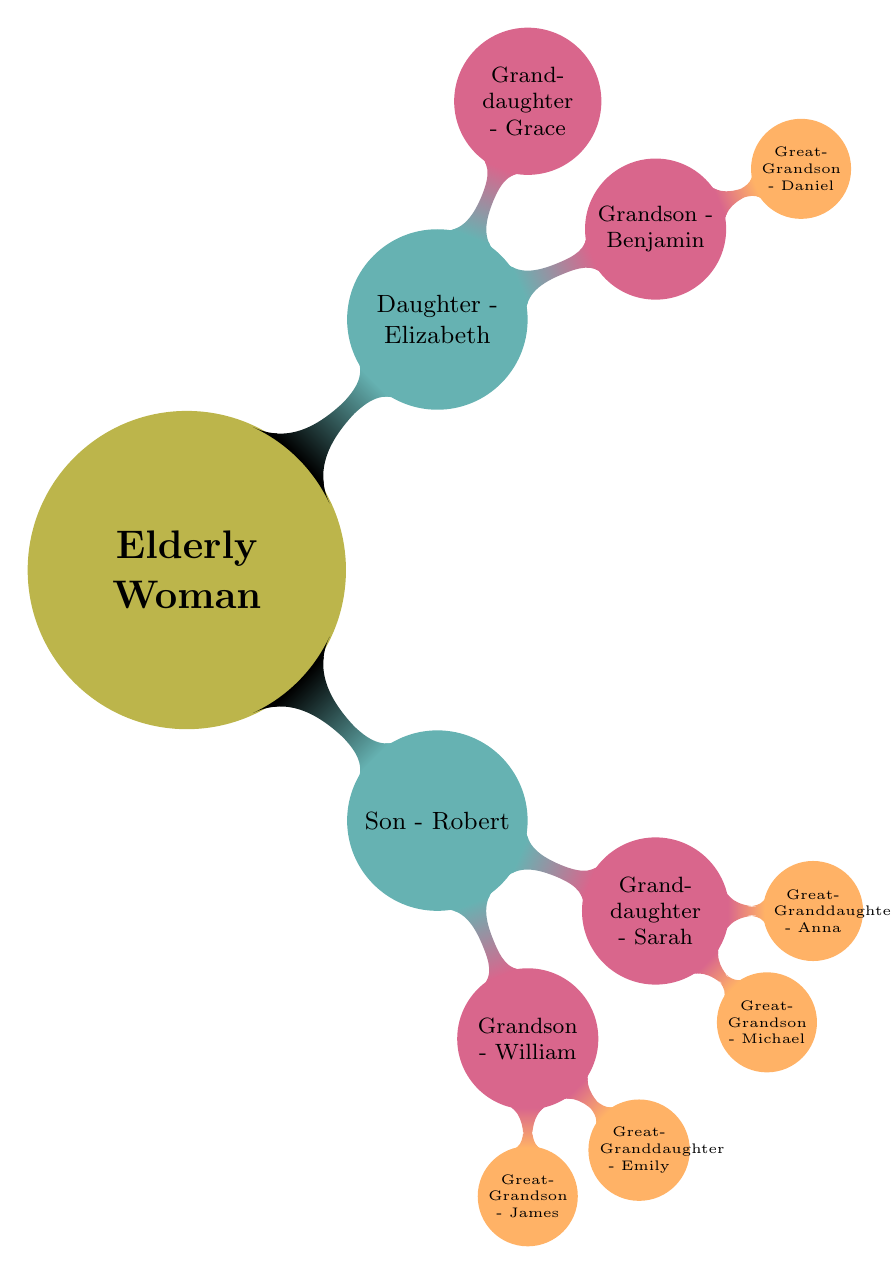What is the root node of the diagram? The root node is labeled "Elderly Woman," which represents the starting point of the family tree.
Answer: Elderly Woman How many children does the Elderly Woman have? The diagram shows two direct children of the Elderly Woman: a son named Robert and a daughter named Elizabeth. Therefore, the count is two.
Answer: 2 Who is the grandson of the Elderly Woman? The grandson is William, who is the child of Robert, one of the Elderly Woman's two children.
Answer: William How many great-grandchildren does Son Robert have? Son Robert has two grandchildren listed, William and Sarah. Each of them has two children, resulting in four great-grandchildren: James, Emily, Michael, and Anna.
Answer: 4 Which granddaughter of the Elderly Woman has a child? The granddaughter Benjamin of Elizabeth is the only one listed who has a child, specifically a great-grandson named Daniel.
Answer: Benjamin How many total generations are depicted in the diagram? The diagram includes four generations: the Elderly Woman (first generation), her children Robert and Elizabeth (second generation), their grandchildren (third generation), and the great-grandchildren (fourth generation), making the total count four generations.
Answer: 4 Who is the great-granddaughter of the Elderly Woman? There are two great-granddaughters listed in the tree: Emily (daughter of William) and Anna (daughter of Sarah).
Answer: Emily and Anna Which child of the Elderly Woman has more children? Son Robert has two children (William and Sarah), while Daughter Elizabeth has two children (Benjamin and Grace). Both children have the same number of children, but Robert's children have children of their own, leading to more total offspring descending from him.
Answer: Son - Robert 